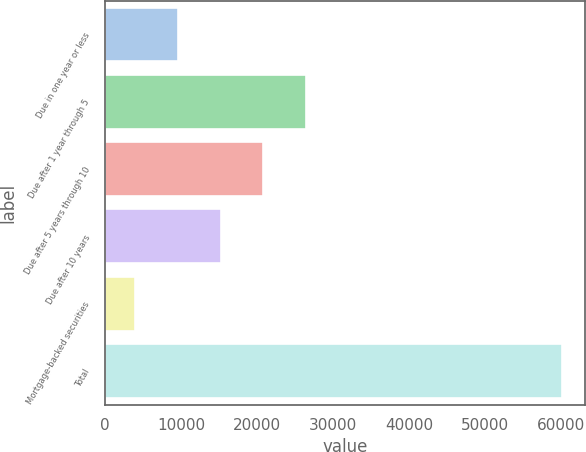Convert chart to OTSL. <chart><loc_0><loc_0><loc_500><loc_500><bar_chart><fcel>Due in one year or less<fcel>Due after 1 year through 5<fcel>Due after 5 years through 10<fcel>Due after 10 years<fcel>Mortgage-backed securities<fcel>Total<nl><fcel>9573.8<fcel>26453.6<fcel>20831.8<fcel>15210<fcel>3952<fcel>60170<nl></chart> 